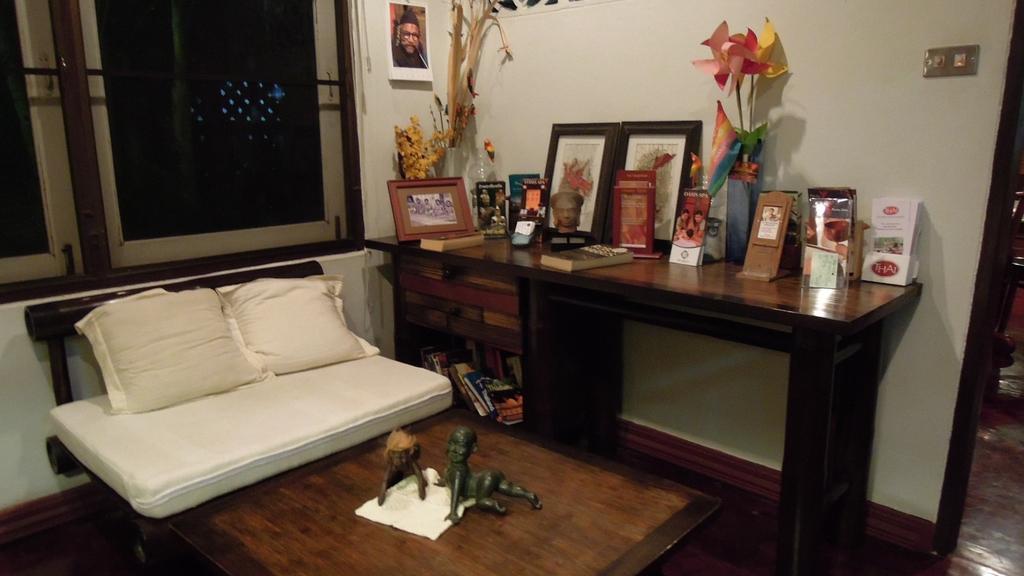In one or two sentences, can you explain what this image depicts? This is inside the room. We can see table,bed. On the bed we can see pillow,toys. On the table we can see Frames and things. This is wall. On the background we can see window. 